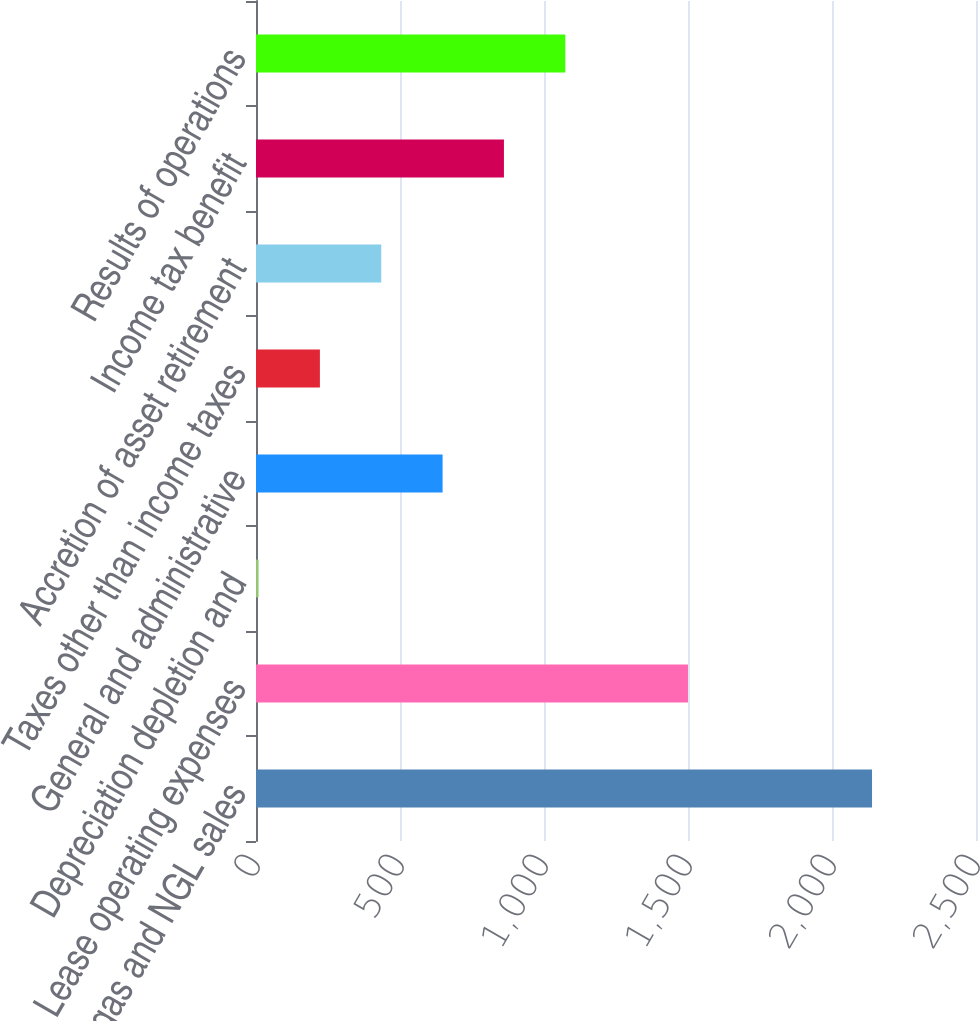Convert chart to OTSL. <chart><loc_0><loc_0><loc_500><loc_500><bar_chart><fcel>Oil gas and NGL sales<fcel>Lease operating expenses<fcel>Depreciation depletion and<fcel>General and administrative<fcel>Taxes other than income taxes<fcel>Accretion of asset retirement<fcel>Income tax benefit<fcel>Results of operations<nl><fcel>2139<fcel>1499.98<fcel>8.84<fcel>647.9<fcel>221.86<fcel>434.88<fcel>860.92<fcel>1073.94<nl></chart> 